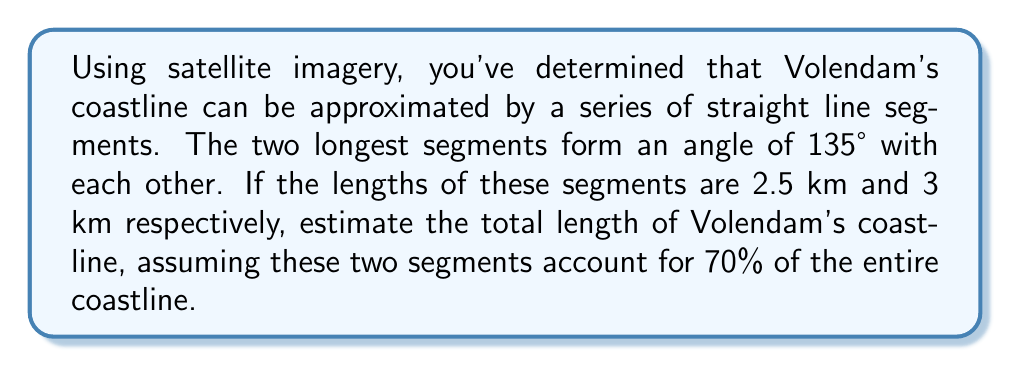Give your solution to this math problem. Let's approach this step-by-step:

1) First, we need to find the length of the two main segments combined. We can use the law of cosines for this:

   Let $c$ be the length we're looking for, $a = 2.5$ km, and $b = 3$ km.
   
   $$c^2 = a^2 + b^2 - 2ab \cos(135°)$$

2) We know that $\cos(135°) = -\frac{\sqrt{2}}{2}$. Let's substitute this:

   $$c^2 = 2.5^2 + 3^2 - 2(2.5)(3)(-\frac{\sqrt{2}}{2})$$

3) Simplify:

   $$c^2 = 6.25 + 9 + 15\sqrt{2} = 15.25 + 15\sqrt{2}$$

4) Take the square root:

   $$c = \sqrt{15.25 + 15\sqrt{2}} \approx 5.22 \text{ km}$$

5) Now, if this 5.22 km represents 70% of the coastline, we can find the total length:

   Let $x$ be the total length of the coastline.
   
   $$5.22 = 0.70x$$

6) Solve for $x$:

   $$x = \frac{5.22}{0.70} \approx 7.46 \text{ km}$$

Therefore, the estimated total length of Volendam's coastline is approximately 7.46 km.
Answer: $7.46 \text{ km}$ 